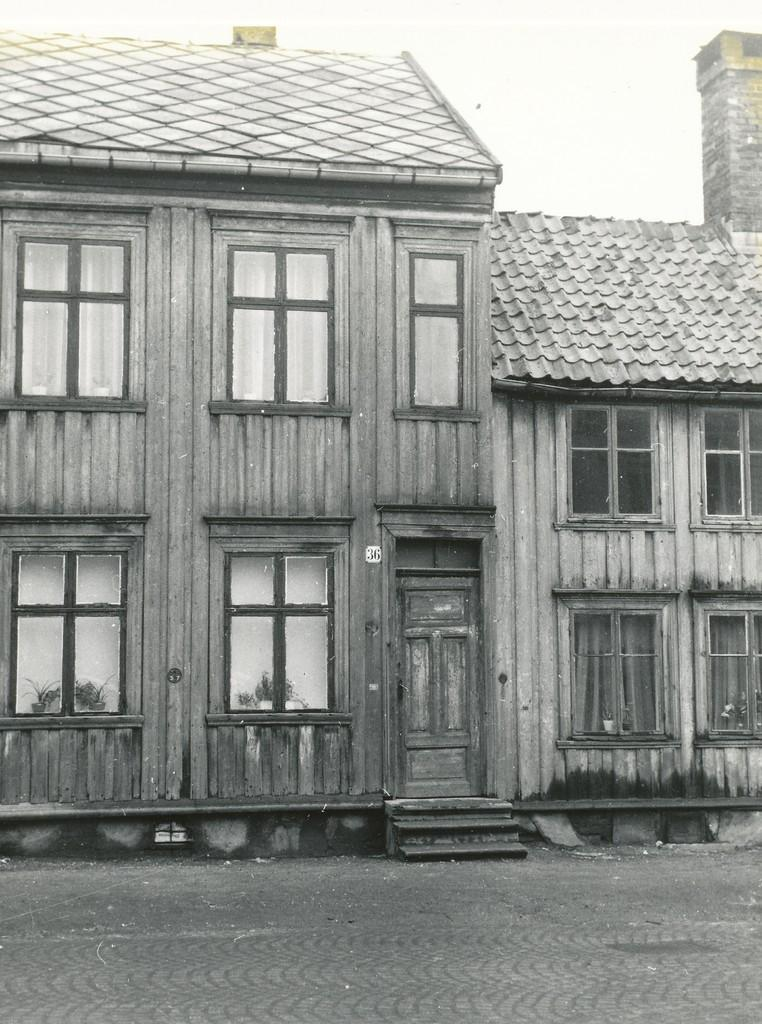What type of image is present in the picture? The image contains a black and white photograph. What is the subject of the photograph? The photograph is of a building. What material is used for the doors of the building? The building has wooden doors. What material is used for the windows of the building? The building has wooden windows. What is the cause of the building jumping in the image? There is no indication in the image that the building is jumping or that any cause for such an event is present. 